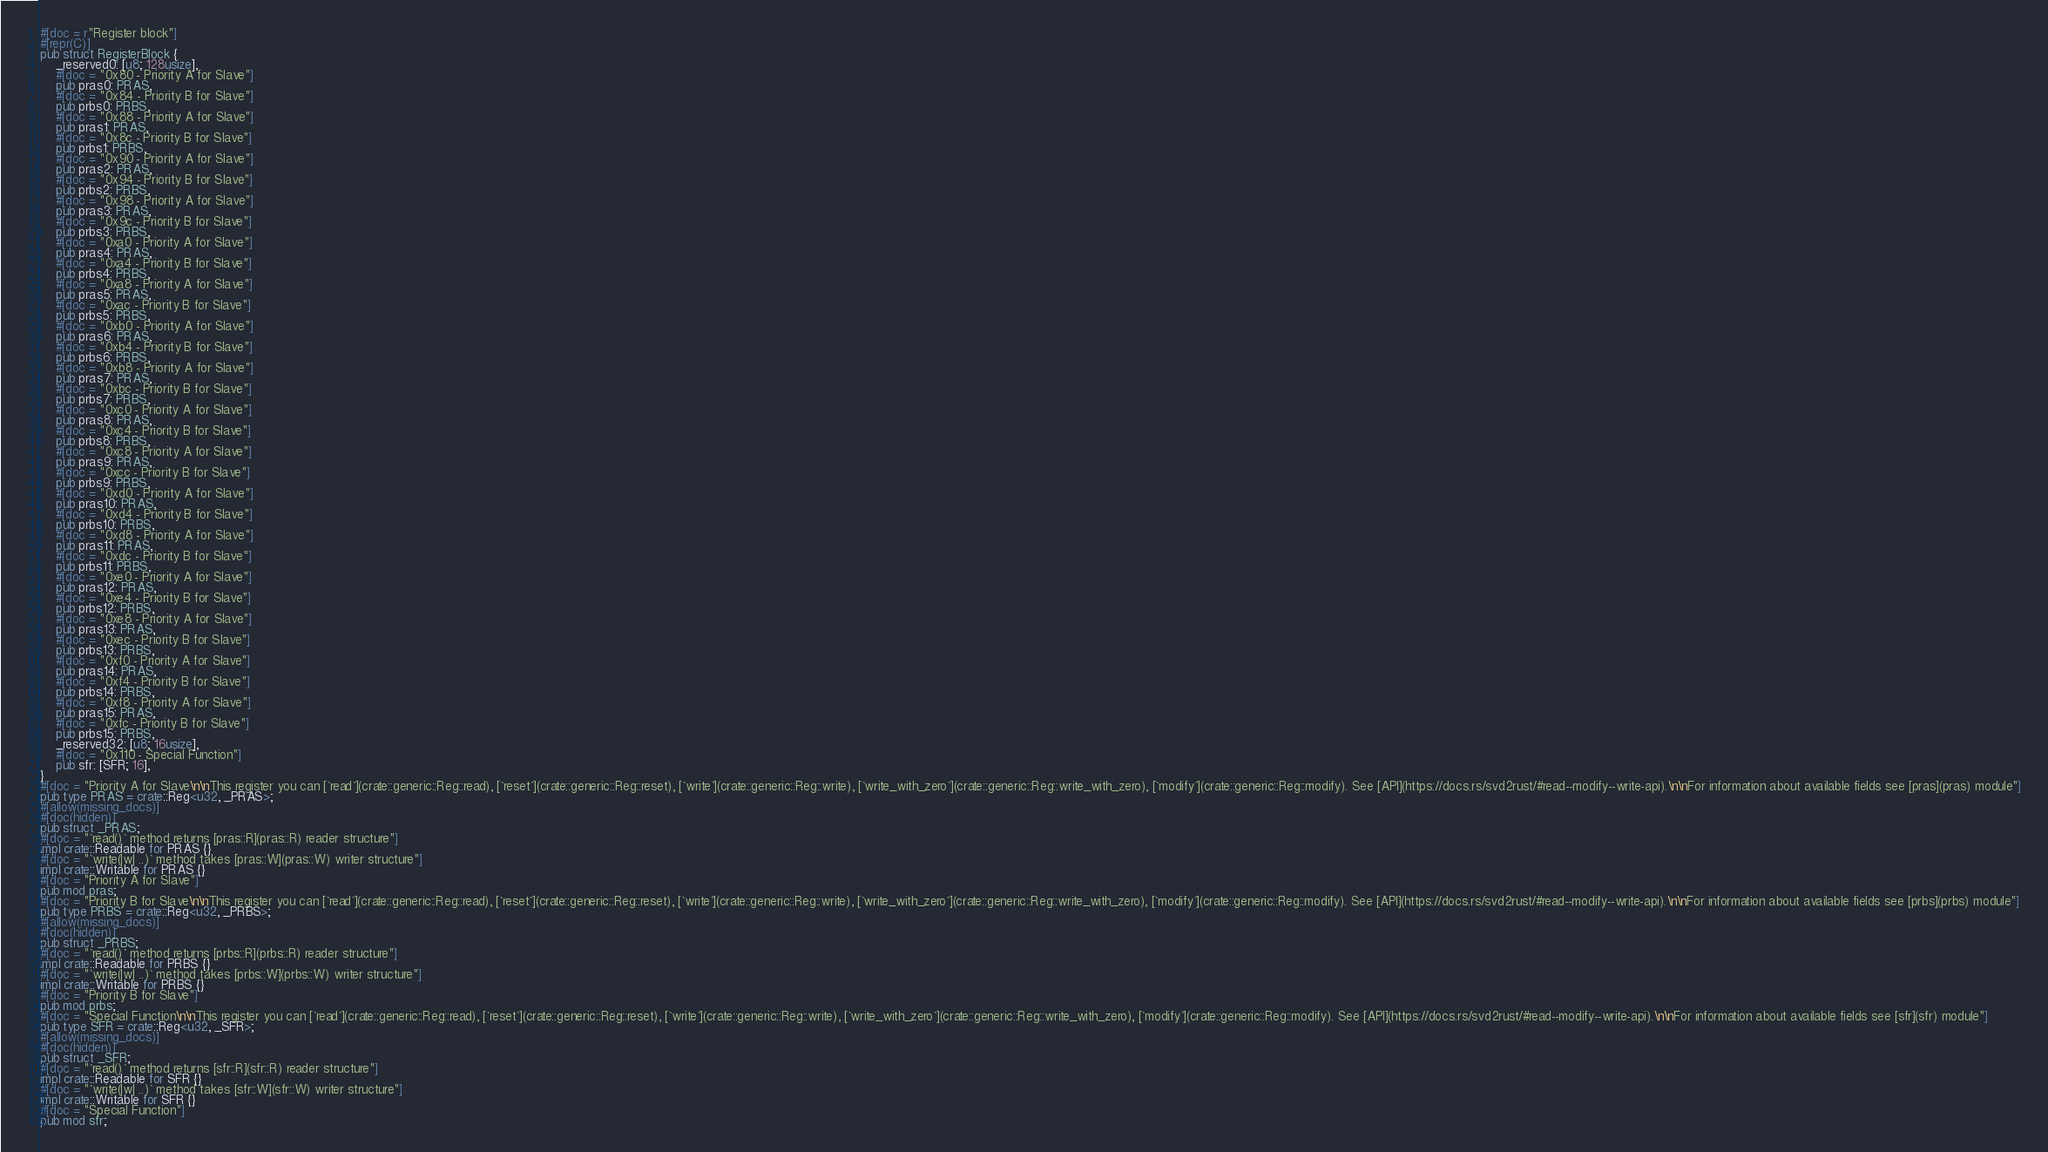Convert code to text. <code><loc_0><loc_0><loc_500><loc_500><_Rust_>#[doc = r"Register block"]
#[repr(C)]
pub struct RegisterBlock {
    _reserved0: [u8; 128usize],
    #[doc = "0x80 - Priority A for Slave"]
    pub pras0: PRAS,
    #[doc = "0x84 - Priority B for Slave"]
    pub prbs0: PRBS,
    #[doc = "0x88 - Priority A for Slave"]
    pub pras1: PRAS,
    #[doc = "0x8c - Priority B for Slave"]
    pub prbs1: PRBS,
    #[doc = "0x90 - Priority A for Slave"]
    pub pras2: PRAS,
    #[doc = "0x94 - Priority B for Slave"]
    pub prbs2: PRBS,
    #[doc = "0x98 - Priority A for Slave"]
    pub pras3: PRAS,
    #[doc = "0x9c - Priority B for Slave"]
    pub prbs3: PRBS,
    #[doc = "0xa0 - Priority A for Slave"]
    pub pras4: PRAS,
    #[doc = "0xa4 - Priority B for Slave"]
    pub prbs4: PRBS,
    #[doc = "0xa8 - Priority A for Slave"]
    pub pras5: PRAS,
    #[doc = "0xac - Priority B for Slave"]
    pub prbs5: PRBS,
    #[doc = "0xb0 - Priority A for Slave"]
    pub pras6: PRAS,
    #[doc = "0xb4 - Priority B for Slave"]
    pub prbs6: PRBS,
    #[doc = "0xb8 - Priority A for Slave"]
    pub pras7: PRAS,
    #[doc = "0xbc - Priority B for Slave"]
    pub prbs7: PRBS,
    #[doc = "0xc0 - Priority A for Slave"]
    pub pras8: PRAS,
    #[doc = "0xc4 - Priority B for Slave"]
    pub prbs8: PRBS,
    #[doc = "0xc8 - Priority A for Slave"]
    pub pras9: PRAS,
    #[doc = "0xcc - Priority B for Slave"]
    pub prbs9: PRBS,
    #[doc = "0xd0 - Priority A for Slave"]
    pub pras10: PRAS,
    #[doc = "0xd4 - Priority B for Slave"]
    pub prbs10: PRBS,
    #[doc = "0xd8 - Priority A for Slave"]
    pub pras11: PRAS,
    #[doc = "0xdc - Priority B for Slave"]
    pub prbs11: PRBS,
    #[doc = "0xe0 - Priority A for Slave"]
    pub pras12: PRAS,
    #[doc = "0xe4 - Priority B for Slave"]
    pub prbs12: PRBS,
    #[doc = "0xe8 - Priority A for Slave"]
    pub pras13: PRAS,
    #[doc = "0xec - Priority B for Slave"]
    pub prbs13: PRBS,
    #[doc = "0xf0 - Priority A for Slave"]
    pub pras14: PRAS,
    #[doc = "0xf4 - Priority B for Slave"]
    pub prbs14: PRBS,
    #[doc = "0xf8 - Priority A for Slave"]
    pub pras15: PRAS,
    #[doc = "0xfc - Priority B for Slave"]
    pub prbs15: PRBS,
    _reserved32: [u8; 16usize],
    #[doc = "0x110 - Special Function"]
    pub sfr: [SFR; 16],
}
#[doc = "Priority A for Slave\n\nThis register you can [`read`](crate::generic::Reg::read), [`reset`](crate::generic::Reg::reset), [`write`](crate::generic::Reg::write), [`write_with_zero`](crate::generic::Reg::write_with_zero), [`modify`](crate::generic::Reg::modify). See [API](https://docs.rs/svd2rust/#read--modify--write-api).\n\nFor information about available fields see [pras](pras) module"]
pub type PRAS = crate::Reg<u32, _PRAS>;
#[allow(missing_docs)]
#[doc(hidden)]
pub struct _PRAS;
#[doc = "`read()` method returns [pras::R](pras::R) reader structure"]
impl crate::Readable for PRAS {}
#[doc = "`write(|w| ..)` method takes [pras::W](pras::W) writer structure"]
impl crate::Writable for PRAS {}
#[doc = "Priority A for Slave"]
pub mod pras;
#[doc = "Priority B for Slave\n\nThis register you can [`read`](crate::generic::Reg::read), [`reset`](crate::generic::Reg::reset), [`write`](crate::generic::Reg::write), [`write_with_zero`](crate::generic::Reg::write_with_zero), [`modify`](crate::generic::Reg::modify). See [API](https://docs.rs/svd2rust/#read--modify--write-api).\n\nFor information about available fields see [prbs](prbs) module"]
pub type PRBS = crate::Reg<u32, _PRBS>;
#[allow(missing_docs)]
#[doc(hidden)]
pub struct _PRBS;
#[doc = "`read()` method returns [prbs::R](prbs::R) reader structure"]
impl crate::Readable for PRBS {}
#[doc = "`write(|w| ..)` method takes [prbs::W](prbs::W) writer structure"]
impl crate::Writable for PRBS {}
#[doc = "Priority B for Slave"]
pub mod prbs;
#[doc = "Special Function\n\nThis register you can [`read`](crate::generic::Reg::read), [`reset`](crate::generic::Reg::reset), [`write`](crate::generic::Reg::write), [`write_with_zero`](crate::generic::Reg::write_with_zero), [`modify`](crate::generic::Reg::modify). See [API](https://docs.rs/svd2rust/#read--modify--write-api).\n\nFor information about available fields see [sfr](sfr) module"]
pub type SFR = crate::Reg<u32, _SFR>;
#[allow(missing_docs)]
#[doc(hidden)]
pub struct _SFR;
#[doc = "`read()` method returns [sfr::R](sfr::R) reader structure"]
impl crate::Readable for SFR {}
#[doc = "`write(|w| ..)` method takes [sfr::W](sfr::W) writer structure"]
impl crate::Writable for SFR {}
#[doc = "Special Function"]
pub mod sfr;
</code> 